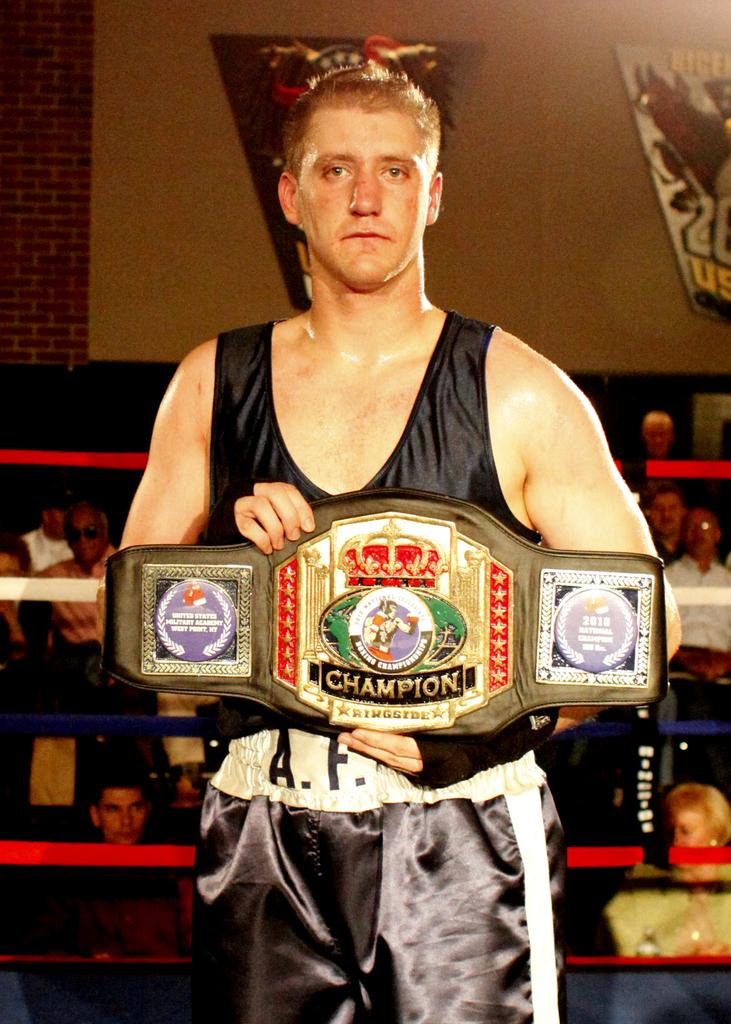<image>
Summarize the visual content of the image. A young man presenting a championship belt of some type with champion ringside written on it. 